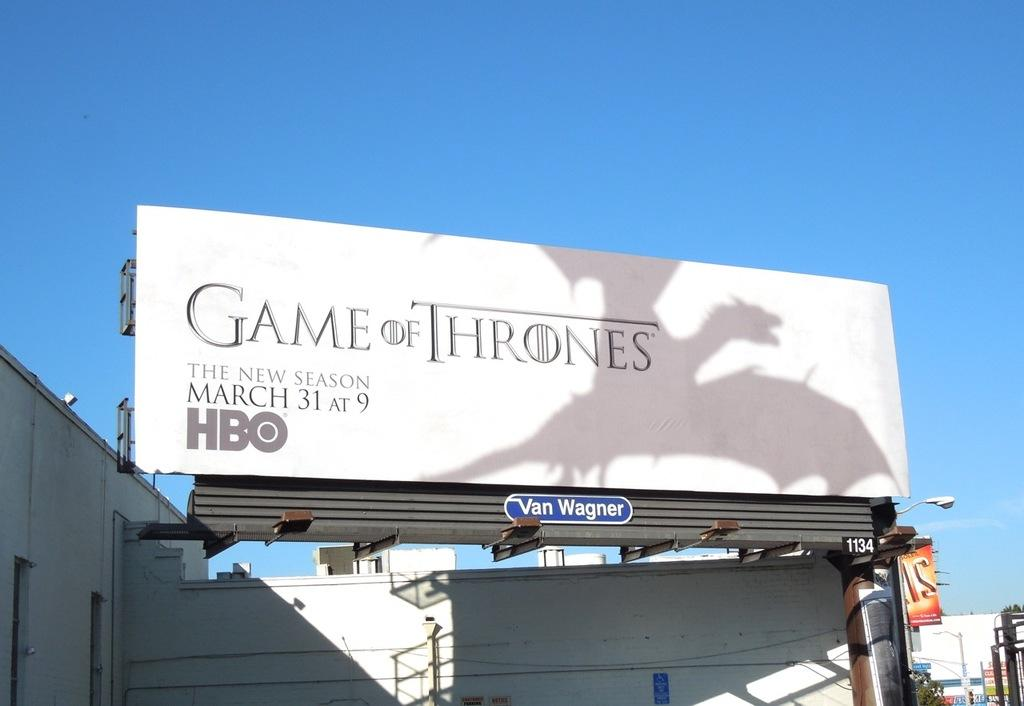Provide a one-sentence caption for the provided image. A promotional billboard for the Game of Thrones is white with a dragon on it and tells people that a new season will start March 31 at 9 on HBO. 